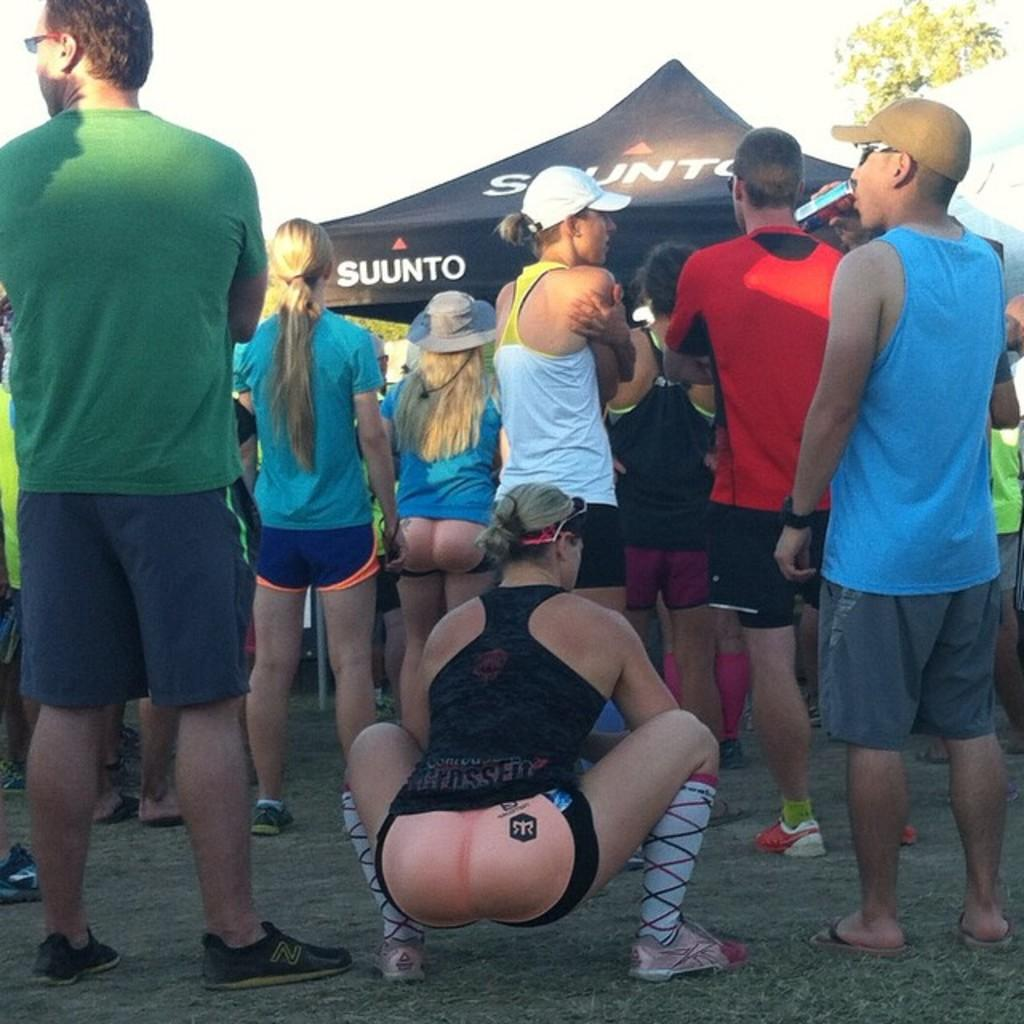<image>
Present a compact description of the photo's key features. People gather at an event near a Suunto canopy. 